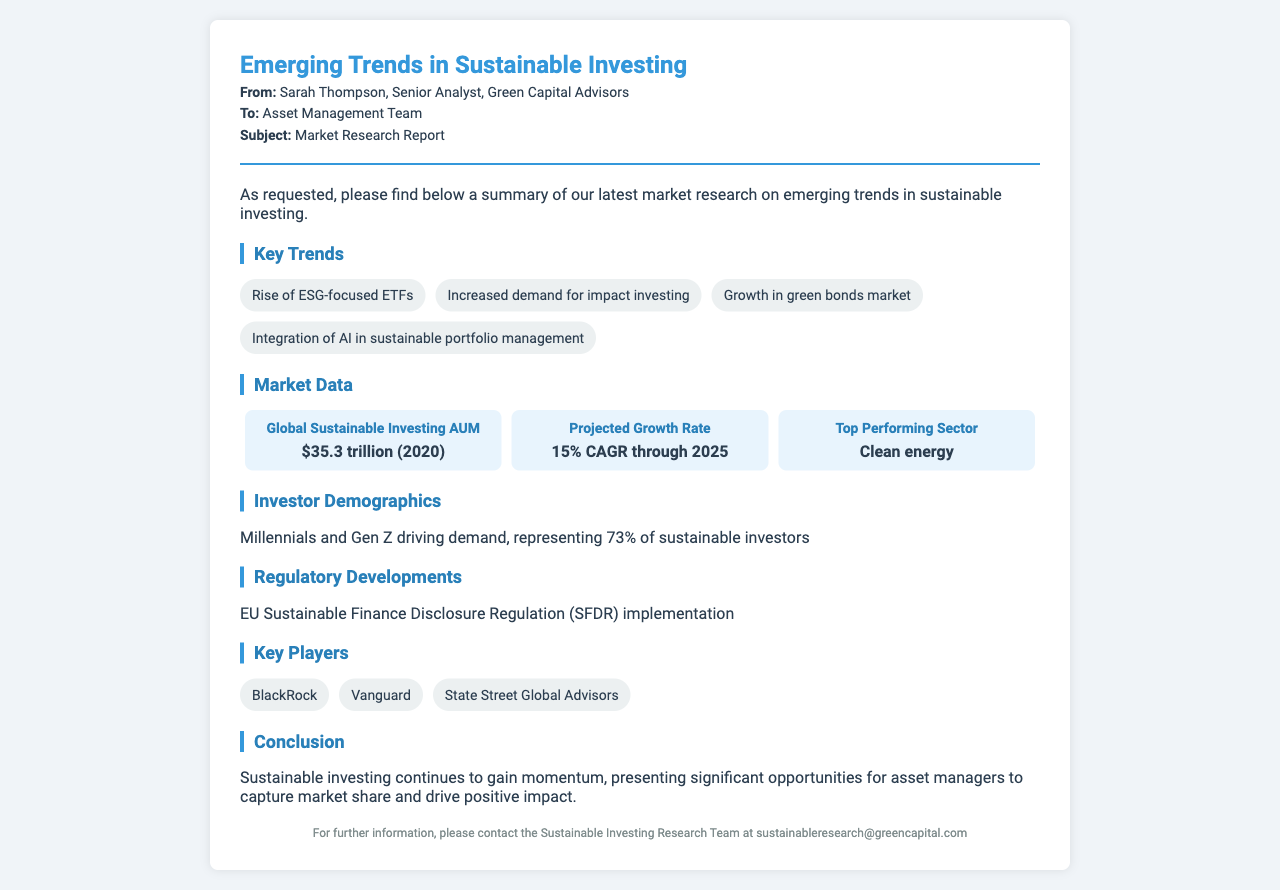what is the title of the fax? The title of the fax is indicated at the top of the document.
Answer: Emerging Trends in Sustainable Investing who is the sender of the fax? The sender is mentioned in the header of the fax.
Answer: Sarah Thompson what is the projected growth rate for sustainable investing? The document provides a specific projection regarding growth in sustainable investing.
Answer: 15% CAGR through 2025 which generation is driving demand for sustainable investing? The document states demographics that are influencing market trends.
Answer: Millennials and Gen Z what percentage of sustainable investors are Millennials and Gen Z? The document gives a specific demographic percentage.
Answer: 73% what is the top-performing sector in sustainable investing? The document specifies which sector is currently leading in performance.
Answer: Clean energy which regulation is mentioned in the document? The fax discusses a specific regulation impacting sustainable investing.
Answer: EU Sustainable Finance Disclosure Regulation (SFDR) name a key player in the sustainable investing space. The document lists several prominent companies in the sector.
Answer: BlackRock how many key trends are highlighted in the document? The number of trends is directly indicated in the section on key trends.
Answer: Four 